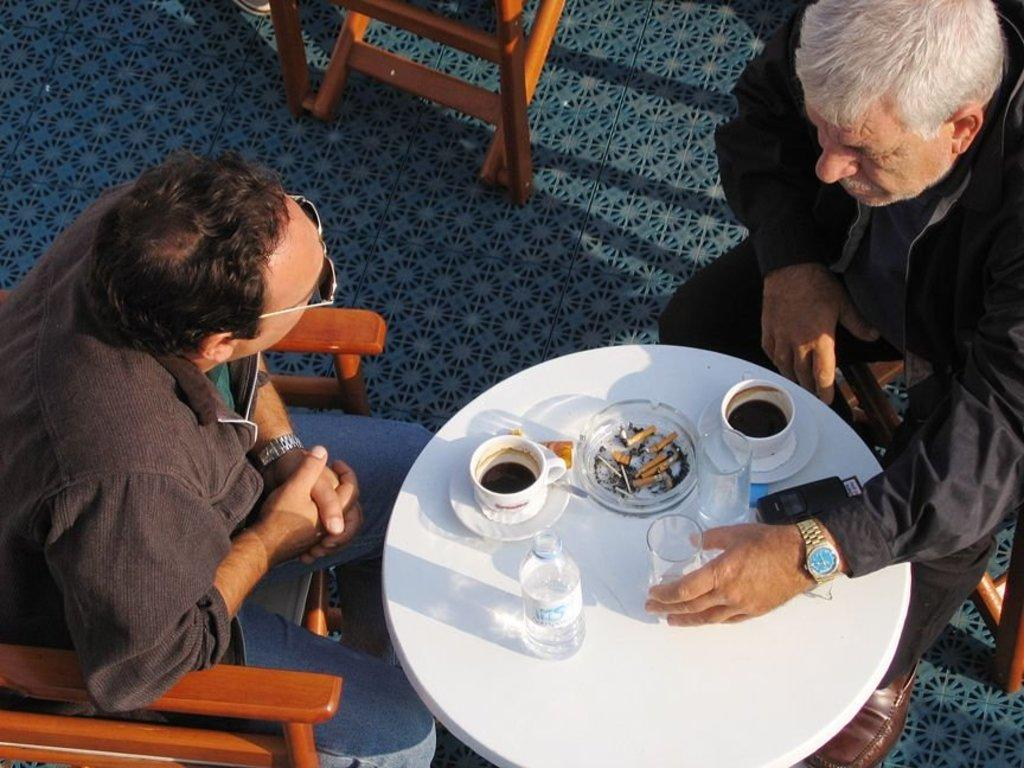How many people are sitting in the image? There are two people sitting on chairs in the image. What can be seen on the table in the image? There are glasses, cups, a saucer, and a bottle on the table. Are there any other objects on the table? Yes, there are other objects on the table. What type of sock is the dog wearing in the image? There is no dog or sock present in the image. How many crackers are on the table in the image? There is no mention of crackers in the image; only glasses, cups, a saucer, a bottle, and other objects are present on the table. 